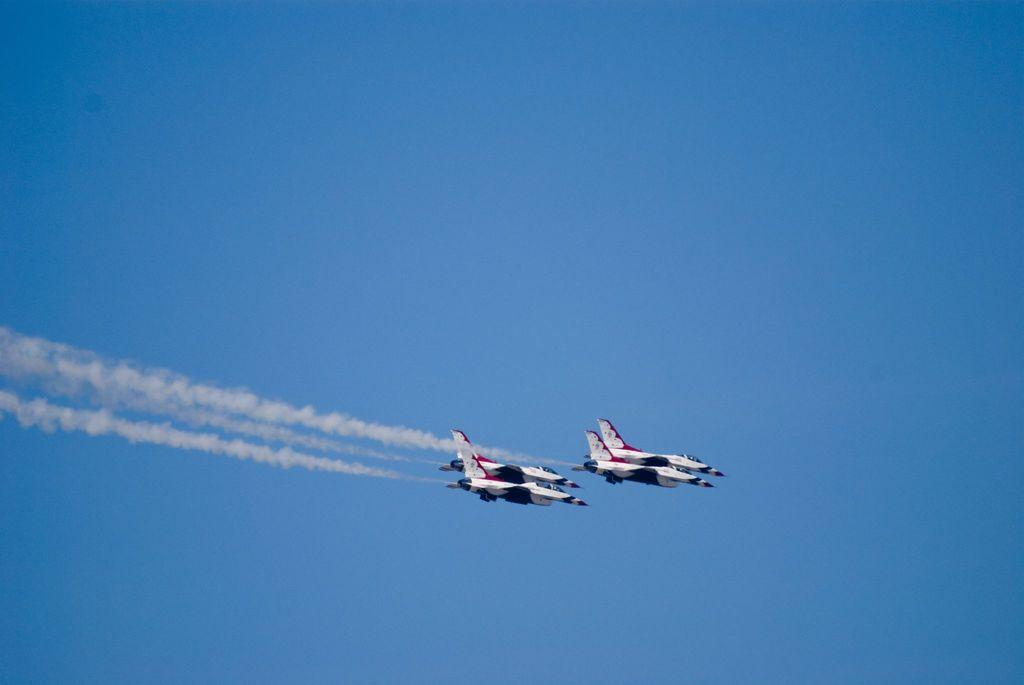What is happening in the sky in the image? There are jets flying in the air in the image, and smoke is coming out from them. What can be seen in the background of the image? The sky is visible in the background of the image. What type of knife is being used to cut the mountain in the image? There is no mountain or knife present in the image; it features jets flying in the air with smoke. 